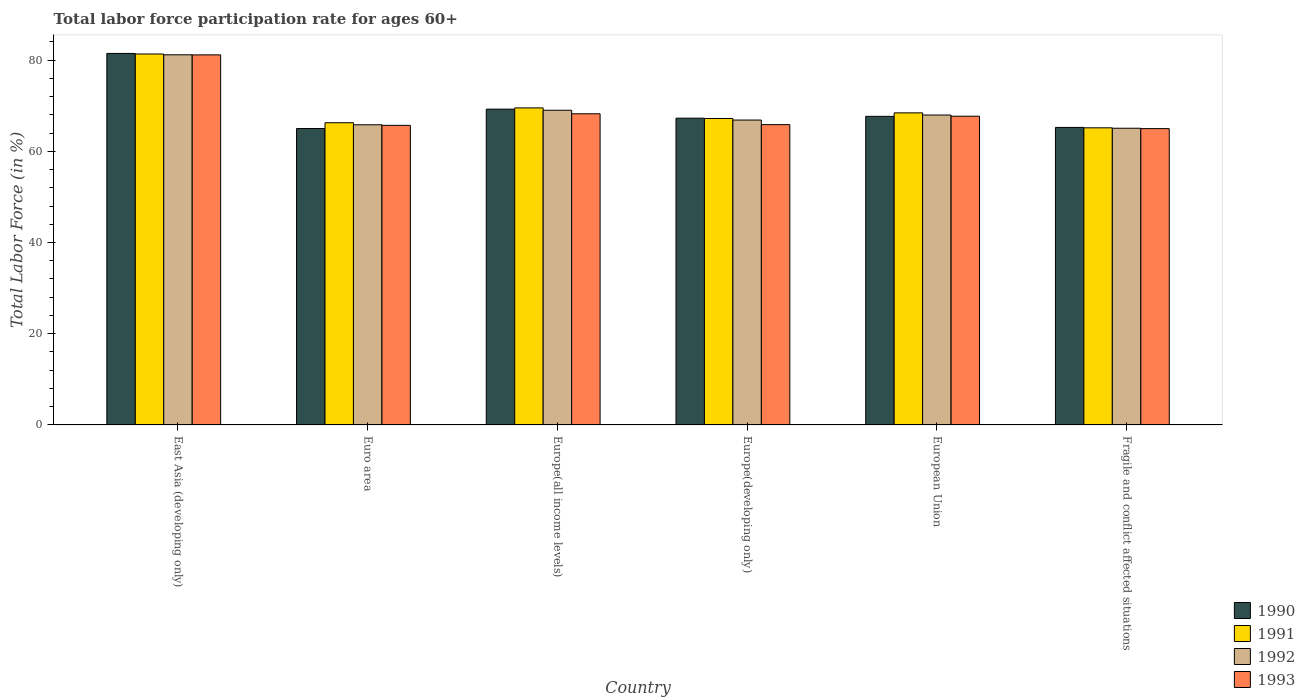Are the number of bars on each tick of the X-axis equal?
Your answer should be compact. Yes. In how many cases, is the number of bars for a given country not equal to the number of legend labels?
Give a very brief answer. 0. What is the labor force participation rate in 1993 in Euro area?
Provide a succinct answer. 65.69. Across all countries, what is the maximum labor force participation rate in 1991?
Provide a short and direct response. 81.33. Across all countries, what is the minimum labor force participation rate in 1990?
Provide a succinct answer. 65. In which country was the labor force participation rate in 1991 maximum?
Your answer should be compact. East Asia (developing only). In which country was the labor force participation rate in 1993 minimum?
Give a very brief answer. Fragile and conflict affected situations. What is the total labor force participation rate in 1991 in the graph?
Offer a terse response. 417.86. What is the difference between the labor force participation rate in 1991 in Euro area and that in Europe(developing only)?
Your answer should be compact. -0.93. What is the difference between the labor force participation rate in 1990 in European Union and the labor force participation rate in 1991 in East Asia (developing only)?
Provide a succinct answer. -13.67. What is the average labor force participation rate in 1990 per country?
Provide a succinct answer. 69.31. What is the difference between the labor force participation rate of/in 1992 and labor force participation rate of/in 1991 in East Asia (developing only)?
Make the answer very short. -0.17. What is the ratio of the labor force participation rate in 1991 in East Asia (developing only) to that in European Union?
Your answer should be compact. 1.19. What is the difference between the highest and the second highest labor force participation rate in 1991?
Make the answer very short. 12.91. What is the difference between the highest and the lowest labor force participation rate in 1990?
Keep it short and to the point. 16.45. Is the sum of the labor force participation rate in 1991 in Europe(all income levels) and European Union greater than the maximum labor force participation rate in 1992 across all countries?
Offer a terse response. Yes. What does the 1st bar from the right in Europe(developing only) represents?
Offer a very short reply. 1993. Is it the case that in every country, the sum of the labor force participation rate in 1992 and labor force participation rate in 1991 is greater than the labor force participation rate in 1993?
Your answer should be very brief. Yes. Are all the bars in the graph horizontal?
Keep it short and to the point. No. What is the difference between two consecutive major ticks on the Y-axis?
Offer a very short reply. 20. Does the graph contain grids?
Offer a very short reply. No. How are the legend labels stacked?
Give a very brief answer. Vertical. What is the title of the graph?
Your answer should be very brief. Total labor force participation rate for ages 60+. What is the label or title of the X-axis?
Provide a succinct answer. Country. What is the Total Labor Force (in %) of 1990 in East Asia (developing only)?
Make the answer very short. 81.45. What is the Total Labor Force (in %) of 1991 in East Asia (developing only)?
Keep it short and to the point. 81.33. What is the Total Labor Force (in %) in 1992 in East Asia (developing only)?
Provide a succinct answer. 81.16. What is the Total Labor Force (in %) in 1993 in East Asia (developing only)?
Offer a very short reply. 81.14. What is the Total Labor Force (in %) in 1990 in Euro area?
Keep it short and to the point. 65. What is the Total Labor Force (in %) in 1991 in Euro area?
Give a very brief answer. 66.26. What is the Total Labor Force (in %) of 1992 in Euro area?
Keep it short and to the point. 65.81. What is the Total Labor Force (in %) of 1993 in Euro area?
Your response must be concise. 65.69. What is the Total Labor Force (in %) of 1990 in Europe(all income levels)?
Give a very brief answer. 69.24. What is the Total Labor Force (in %) of 1991 in Europe(all income levels)?
Make the answer very short. 69.51. What is the Total Labor Force (in %) in 1992 in Europe(all income levels)?
Provide a succinct answer. 68.99. What is the Total Labor Force (in %) in 1993 in Europe(all income levels)?
Make the answer very short. 68.22. What is the Total Labor Force (in %) in 1990 in Europe(developing only)?
Offer a terse response. 67.26. What is the Total Labor Force (in %) in 1991 in Europe(developing only)?
Offer a very short reply. 67.19. What is the Total Labor Force (in %) of 1992 in Europe(developing only)?
Offer a very short reply. 66.85. What is the Total Labor Force (in %) of 1993 in Europe(developing only)?
Your response must be concise. 65.84. What is the Total Labor Force (in %) of 1990 in European Union?
Ensure brevity in your answer.  67.66. What is the Total Labor Force (in %) in 1991 in European Union?
Give a very brief answer. 68.42. What is the Total Labor Force (in %) of 1992 in European Union?
Your response must be concise. 67.95. What is the Total Labor Force (in %) in 1993 in European Union?
Ensure brevity in your answer.  67.69. What is the Total Labor Force (in %) in 1990 in Fragile and conflict affected situations?
Offer a very short reply. 65.24. What is the Total Labor Force (in %) in 1991 in Fragile and conflict affected situations?
Ensure brevity in your answer.  65.15. What is the Total Labor Force (in %) of 1992 in Fragile and conflict affected situations?
Offer a very short reply. 65.05. What is the Total Labor Force (in %) of 1993 in Fragile and conflict affected situations?
Your answer should be compact. 64.97. Across all countries, what is the maximum Total Labor Force (in %) in 1990?
Offer a terse response. 81.45. Across all countries, what is the maximum Total Labor Force (in %) in 1991?
Your response must be concise. 81.33. Across all countries, what is the maximum Total Labor Force (in %) in 1992?
Provide a succinct answer. 81.16. Across all countries, what is the maximum Total Labor Force (in %) of 1993?
Your response must be concise. 81.14. Across all countries, what is the minimum Total Labor Force (in %) in 1990?
Ensure brevity in your answer.  65. Across all countries, what is the minimum Total Labor Force (in %) in 1991?
Offer a terse response. 65.15. Across all countries, what is the minimum Total Labor Force (in %) in 1992?
Your answer should be compact. 65.05. Across all countries, what is the minimum Total Labor Force (in %) of 1993?
Give a very brief answer. 64.97. What is the total Total Labor Force (in %) of 1990 in the graph?
Make the answer very short. 415.85. What is the total Total Labor Force (in %) in 1991 in the graph?
Make the answer very short. 417.86. What is the total Total Labor Force (in %) in 1992 in the graph?
Keep it short and to the point. 415.81. What is the total Total Labor Force (in %) in 1993 in the graph?
Your answer should be compact. 413.55. What is the difference between the Total Labor Force (in %) of 1990 in East Asia (developing only) and that in Euro area?
Your answer should be very brief. 16.45. What is the difference between the Total Labor Force (in %) of 1991 in East Asia (developing only) and that in Euro area?
Your answer should be very brief. 15.07. What is the difference between the Total Labor Force (in %) in 1992 in East Asia (developing only) and that in Euro area?
Give a very brief answer. 15.34. What is the difference between the Total Labor Force (in %) of 1993 in East Asia (developing only) and that in Euro area?
Your answer should be compact. 15.45. What is the difference between the Total Labor Force (in %) in 1990 in East Asia (developing only) and that in Europe(all income levels)?
Offer a very short reply. 12.21. What is the difference between the Total Labor Force (in %) in 1991 in East Asia (developing only) and that in Europe(all income levels)?
Make the answer very short. 11.82. What is the difference between the Total Labor Force (in %) of 1992 in East Asia (developing only) and that in Europe(all income levels)?
Keep it short and to the point. 12.17. What is the difference between the Total Labor Force (in %) in 1993 in East Asia (developing only) and that in Europe(all income levels)?
Your answer should be compact. 12.91. What is the difference between the Total Labor Force (in %) of 1990 in East Asia (developing only) and that in Europe(developing only)?
Keep it short and to the point. 14.2. What is the difference between the Total Labor Force (in %) in 1991 in East Asia (developing only) and that in Europe(developing only)?
Your answer should be compact. 14.14. What is the difference between the Total Labor Force (in %) of 1992 in East Asia (developing only) and that in Europe(developing only)?
Keep it short and to the point. 14.31. What is the difference between the Total Labor Force (in %) of 1993 in East Asia (developing only) and that in Europe(developing only)?
Ensure brevity in your answer.  15.29. What is the difference between the Total Labor Force (in %) in 1990 in East Asia (developing only) and that in European Union?
Your answer should be compact. 13.79. What is the difference between the Total Labor Force (in %) in 1991 in East Asia (developing only) and that in European Union?
Provide a succinct answer. 12.91. What is the difference between the Total Labor Force (in %) of 1992 in East Asia (developing only) and that in European Union?
Keep it short and to the point. 13.21. What is the difference between the Total Labor Force (in %) in 1993 in East Asia (developing only) and that in European Union?
Keep it short and to the point. 13.45. What is the difference between the Total Labor Force (in %) of 1990 in East Asia (developing only) and that in Fragile and conflict affected situations?
Provide a short and direct response. 16.22. What is the difference between the Total Labor Force (in %) in 1991 in East Asia (developing only) and that in Fragile and conflict affected situations?
Provide a succinct answer. 16.19. What is the difference between the Total Labor Force (in %) in 1992 in East Asia (developing only) and that in Fragile and conflict affected situations?
Offer a terse response. 16.1. What is the difference between the Total Labor Force (in %) in 1993 in East Asia (developing only) and that in Fragile and conflict affected situations?
Make the answer very short. 16.17. What is the difference between the Total Labor Force (in %) of 1990 in Euro area and that in Europe(all income levels)?
Your answer should be very brief. -4.24. What is the difference between the Total Labor Force (in %) of 1991 in Euro area and that in Europe(all income levels)?
Make the answer very short. -3.25. What is the difference between the Total Labor Force (in %) in 1992 in Euro area and that in Europe(all income levels)?
Your answer should be very brief. -3.18. What is the difference between the Total Labor Force (in %) of 1993 in Euro area and that in Europe(all income levels)?
Make the answer very short. -2.54. What is the difference between the Total Labor Force (in %) in 1990 in Euro area and that in Europe(developing only)?
Ensure brevity in your answer.  -2.26. What is the difference between the Total Labor Force (in %) of 1991 in Euro area and that in Europe(developing only)?
Your answer should be compact. -0.93. What is the difference between the Total Labor Force (in %) in 1992 in Euro area and that in Europe(developing only)?
Ensure brevity in your answer.  -1.03. What is the difference between the Total Labor Force (in %) of 1993 in Euro area and that in Europe(developing only)?
Offer a terse response. -0.16. What is the difference between the Total Labor Force (in %) in 1990 in Euro area and that in European Union?
Give a very brief answer. -2.66. What is the difference between the Total Labor Force (in %) of 1991 in Euro area and that in European Union?
Your response must be concise. -2.16. What is the difference between the Total Labor Force (in %) of 1992 in Euro area and that in European Union?
Your response must be concise. -2.14. What is the difference between the Total Labor Force (in %) of 1993 in Euro area and that in European Union?
Provide a succinct answer. -2.01. What is the difference between the Total Labor Force (in %) of 1990 in Euro area and that in Fragile and conflict affected situations?
Offer a terse response. -0.24. What is the difference between the Total Labor Force (in %) of 1991 in Euro area and that in Fragile and conflict affected situations?
Ensure brevity in your answer.  1.11. What is the difference between the Total Labor Force (in %) in 1992 in Euro area and that in Fragile and conflict affected situations?
Give a very brief answer. 0.76. What is the difference between the Total Labor Force (in %) of 1993 in Euro area and that in Fragile and conflict affected situations?
Keep it short and to the point. 0.72. What is the difference between the Total Labor Force (in %) in 1990 in Europe(all income levels) and that in Europe(developing only)?
Your response must be concise. 1.99. What is the difference between the Total Labor Force (in %) of 1991 in Europe(all income levels) and that in Europe(developing only)?
Offer a very short reply. 2.33. What is the difference between the Total Labor Force (in %) of 1992 in Europe(all income levels) and that in Europe(developing only)?
Give a very brief answer. 2.15. What is the difference between the Total Labor Force (in %) in 1993 in Europe(all income levels) and that in Europe(developing only)?
Offer a very short reply. 2.38. What is the difference between the Total Labor Force (in %) of 1990 in Europe(all income levels) and that in European Union?
Offer a very short reply. 1.58. What is the difference between the Total Labor Force (in %) in 1991 in Europe(all income levels) and that in European Union?
Your answer should be compact. 1.09. What is the difference between the Total Labor Force (in %) of 1992 in Europe(all income levels) and that in European Union?
Your response must be concise. 1.04. What is the difference between the Total Labor Force (in %) in 1993 in Europe(all income levels) and that in European Union?
Ensure brevity in your answer.  0.53. What is the difference between the Total Labor Force (in %) of 1990 in Europe(all income levels) and that in Fragile and conflict affected situations?
Ensure brevity in your answer.  4.01. What is the difference between the Total Labor Force (in %) in 1991 in Europe(all income levels) and that in Fragile and conflict affected situations?
Give a very brief answer. 4.37. What is the difference between the Total Labor Force (in %) in 1992 in Europe(all income levels) and that in Fragile and conflict affected situations?
Offer a very short reply. 3.94. What is the difference between the Total Labor Force (in %) in 1993 in Europe(all income levels) and that in Fragile and conflict affected situations?
Keep it short and to the point. 3.26. What is the difference between the Total Labor Force (in %) of 1990 in Europe(developing only) and that in European Union?
Your answer should be very brief. -0.4. What is the difference between the Total Labor Force (in %) of 1991 in Europe(developing only) and that in European Union?
Make the answer very short. -1.24. What is the difference between the Total Labor Force (in %) in 1992 in Europe(developing only) and that in European Union?
Give a very brief answer. -1.1. What is the difference between the Total Labor Force (in %) of 1993 in Europe(developing only) and that in European Union?
Your answer should be compact. -1.85. What is the difference between the Total Labor Force (in %) of 1990 in Europe(developing only) and that in Fragile and conflict affected situations?
Give a very brief answer. 2.02. What is the difference between the Total Labor Force (in %) of 1991 in Europe(developing only) and that in Fragile and conflict affected situations?
Provide a succinct answer. 2.04. What is the difference between the Total Labor Force (in %) in 1992 in Europe(developing only) and that in Fragile and conflict affected situations?
Your answer should be very brief. 1.79. What is the difference between the Total Labor Force (in %) of 1993 in Europe(developing only) and that in Fragile and conflict affected situations?
Offer a very short reply. 0.87. What is the difference between the Total Labor Force (in %) of 1990 in European Union and that in Fragile and conflict affected situations?
Your response must be concise. 2.42. What is the difference between the Total Labor Force (in %) of 1991 in European Union and that in Fragile and conflict affected situations?
Keep it short and to the point. 3.28. What is the difference between the Total Labor Force (in %) of 1992 in European Union and that in Fragile and conflict affected situations?
Ensure brevity in your answer.  2.9. What is the difference between the Total Labor Force (in %) of 1993 in European Union and that in Fragile and conflict affected situations?
Your response must be concise. 2.72. What is the difference between the Total Labor Force (in %) in 1990 in East Asia (developing only) and the Total Labor Force (in %) in 1991 in Euro area?
Keep it short and to the point. 15.19. What is the difference between the Total Labor Force (in %) of 1990 in East Asia (developing only) and the Total Labor Force (in %) of 1992 in Euro area?
Give a very brief answer. 15.64. What is the difference between the Total Labor Force (in %) of 1990 in East Asia (developing only) and the Total Labor Force (in %) of 1993 in Euro area?
Your response must be concise. 15.77. What is the difference between the Total Labor Force (in %) of 1991 in East Asia (developing only) and the Total Labor Force (in %) of 1992 in Euro area?
Provide a succinct answer. 15.52. What is the difference between the Total Labor Force (in %) of 1991 in East Asia (developing only) and the Total Labor Force (in %) of 1993 in Euro area?
Give a very brief answer. 15.65. What is the difference between the Total Labor Force (in %) in 1992 in East Asia (developing only) and the Total Labor Force (in %) in 1993 in Euro area?
Offer a terse response. 15.47. What is the difference between the Total Labor Force (in %) in 1990 in East Asia (developing only) and the Total Labor Force (in %) in 1991 in Europe(all income levels)?
Make the answer very short. 11.94. What is the difference between the Total Labor Force (in %) of 1990 in East Asia (developing only) and the Total Labor Force (in %) of 1992 in Europe(all income levels)?
Offer a terse response. 12.46. What is the difference between the Total Labor Force (in %) of 1990 in East Asia (developing only) and the Total Labor Force (in %) of 1993 in Europe(all income levels)?
Your answer should be compact. 13.23. What is the difference between the Total Labor Force (in %) of 1991 in East Asia (developing only) and the Total Labor Force (in %) of 1992 in Europe(all income levels)?
Keep it short and to the point. 12.34. What is the difference between the Total Labor Force (in %) in 1991 in East Asia (developing only) and the Total Labor Force (in %) in 1993 in Europe(all income levels)?
Offer a very short reply. 13.11. What is the difference between the Total Labor Force (in %) of 1992 in East Asia (developing only) and the Total Labor Force (in %) of 1993 in Europe(all income levels)?
Provide a short and direct response. 12.93. What is the difference between the Total Labor Force (in %) of 1990 in East Asia (developing only) and the Total Labor Force (in %) of 1991 in Europe(developing only)?
Offer a very short reply. 14.27. What is the difference between the Total Labor Force (in %) in 1990 in East Asia (developing only) and the Total Labor Force (in %) in 1992 in Europe(developing only)?
Your answer should be compact. 14.61. What is the difference between the Total Labor Force (in %) of 1990 in East Asia (developing only) and the Total Labor Force (in %) of 1993 in Europe(developing only)?
Give a very brief answer. 15.61. What is the difference between the Total Labor Force (in %) in 1991 in East Asia (developing only) and the Total Labor Force (in %) in 1992 in Europe(developing only)?
Give a very brief answer. 14.49. What is the difference between the Total Labor Force (in %) of 1991 in East Asia (developing only) and the Total Labor Force (in %) of 1993 in Europe(developing only)?
Your answer should be compact. 15.49. What is the difference between the Total Labor Force (in %) in 1992 in East Asia (developing only) and the Total Labor Force (in %) in 1993 in Europe(developing only)?
Ensure brevity in your answer.  15.31. What is the difference between the Total Labor Force (in %) in 1990 in East Asia (developing only) and the Total Labor Force (in %) in 1991 in European Union?
Keep it short and to the point. 13.03. What is the difference between the Total Labor Force (in %) of 1990 in East Asia (developing only) and the Total Labor Force (in %) of 1992 in European Union?
Make the answer very short. 13.5. What is the difference between the Total Labor Force (in %) in 1990 in East Asia (developing only) and the Total Labor Force (in %) in 1993 in European Union?
Give a very brief answer. 13.76. What is the difference between the Total Labor Force (in %) of 1991 in East Asia (developing only) and the Total Labor Force (in %) of 1992 in European Union?
Make the answer very short. 13.38. What is the difference between the Total Labor Force (in %) in 1991 in East Asia (developing only) and the Total Labor Force (in %) in 1993 in European Union?
Provide a succinct answer. 13.64. What is the difference between the Total Labor Force (in %) in 1992 in East Asia (developing only) and the Total Labor Force (in %) in 1993 in European Union?
Offer a terse response. 13.47. What is the difference between the Total Labor Force (in %) in 1990 in East Asia (developing only) and the Total Labor Force (in %) in 1991 in Fragile and conflict affected situations?
Provide a succinct answer. 16.31. What is the difference between the Total Labor Force (in %) of 1990 in East Asia (developing only) and the Total Labor Force (in %) of 1992 in Fragile and conflict affected situations?
Give a very brief answer. 16.4. What is the difference between the Total Labor Force (in %) of 1990 in East Asia (developing only) and the Total Labor Force (in %) of 1993 in Fragile and conflict affected situations?
Make the answer very short. 16.48. What is the difference between the Total Labor Force (in %) of 1991 in East Asia (developing only) and the Total Labor Force (in %) of 1992 in Fragile and conflict affected situations?
Offer a very short reply. 16.28. What is the difference between the Total Labor Force (in %) of 1991 in East Asia (developing only) and the Total Labor Force (in %) of 1993 in Fragile and conflict affected situations?
Offer a very short reply. 16.36. What is the difference between the Total Labor Force (in %) in 1992 in East Asia (developing only) and the Total Labor Force (in %) in 1993 in Fragile and conflict affected situations?
Offer a very short reply. 16.19. What is the difference between the Total Labor Force (in %) of 1990 in Euro area and the Total Labor Force (in %) of 1991 in Europe(all income levels)?
Your response must be concise. -4.51. What is the difference between the Total Labor Force (in %) of 1990 in Euro area and the Total Labor Force (in %) of 1992 in Europe(all income levels)?
Ensure brevity in your answer.  -3.99. What is the difference between the Total Labor Force (in %) in 1990 in Euro area and the Total Labor Force (in %) in 1993 in Europe(all income levels)?
Keep it short and to the point. -3.22. What is the difference between the Total Labor Force (in %) of 1991 in Euro area and the Total Labor Force (in %) of 1992 in Europe(all income levels)?
Your response must be concise. -2.73. What is the difference between the Total Labor Force (in %) of 1991 in Euro area and the Total Labor Force (in %) of 1993 in Europe(all income levels)?
Give a very brief answer. -1.97. What is the difference between the Total Labor Force (in %) of 1992 in Euro area and the Total Labor Force (in %) of 1993 in Europe(all income levels)?
Offer a terse response. -2.41. What is the difference between the Total Labor Force (in %) of 1990 in Euro area and the Total Labor Force (in %) of 1991 in Europe(developing only)?
Offer a very short reply. -2.19. What is the difference between the Total Labor Force (in %) of 1990 in Euro area and the Total Labor Force (in %) of 1992 in Europe(developing only)?
Offer a terse response. -1.85. What is the difference between the Total Labor Force (in %) in 1990 in Euro area and the Total Labor Force (in %) in 1993 in Europe(developing only)?
Your response must be concise. -0.84. What is the difference between the Total Labor Force (in %) in 1991 in Euro area and the Total Labor Force (in %) in 1992 in Europe(developing only)?
Your answer should be compact. -0.59. What is the difference between the Total Labor Force (in %) of 1991 in Euro area and the Total Labor Force (in %) of 1993 in Europe(developing only)?
Make the answer very short. 0.42. What is the difference between the Total Labor Force (in %) in 1992 in Euro area and the Total Labor Force (in %) in 1993 in Europe(developing only)?
Your answer should be very brief. -0.03. What is the difference between the Total Labor Force (in %) in 1990 in Euro area and the Total Labor Force (in %) in 1991 in European Union?
Your response must be concise. -3.42. What is the difference between the Total Labor Force (in %) of 1990 in Euro area and the Total Labor Force (in %) of 1992 in European Union?
Keep it short and to the point. -2.95. What is the difference between the Total Labor Force (in %) in 1990 in Euro area and the Total Labor Force (in %) in 1993 in European Union?
Offer a terse response. -2.69. What is the difference between the Total Labor Force (in %) in 1991 in Euro area and the Total Labor Force (in %) in 1992 in European Union?
Keep it short and to the point. -1.69. What is the difference between the Total Labor Force (in %) in 1991 in Euro area and the Total Labor Force (in %) in 1993 in European Union?
Make the answer very short. -1.43. What is the difference between the Total Labor Force (in %) of 1992 in Euro area and the Total Labor Force (in %) of 1993 in European Union?
Your response must be concise. -1.88. What is the difference between the Total Labor Force (in %) of 1990 in Euro area and the Total Labor Force (in %) of 1991 in Fragile and conflict affected situations?
Make the answer very short. -0.15. What is the difference between the Total Labor Force (in %) of 1990 in Euro area and the Total Labor Force (in %) of 1992 in Fragile and conflict affected situations?
Your answer should be compact. -0.05. What is the difference between the Total Labor Force (in %) of 1990 in Euro area and the Total Labor Force (in %) of 1993 in Fragile and conflict affected situations?
Keep it short and to the point. 0.03. What is the difference between the Total Labor Force (in %) of 1991 in Euro area and the Total Labor Force (in %) of 1992 in Fragile and conflict affected situations?
Make the answer very short. 1.21. What is the difference between the Total Labor Force (in %) of 1991 in Euro area and the Total Labor Force (in %) of 1993 in Fragile and conflict affected situations?
Provide a succinct answer. 1.29. What is the difference between the Total Labor Force (in %) of 1992 in Euro area and the Total Labor Force (in %) of 1993 in Fragile and conflict affected situations?
Provide a succinct answer. 0.84. What is the difference between the Total Labor Force (in %) in 1990 in Europe(all income levels) and the Total Labor Force (in %) in 1991 in Europe(developing only)?
Give a very brief answer. 2.06. What is the difference between the Total Labor Force (in %) in 1990 in Europe(all income levels) and the Total Labor Force (in %) in 1992 in Europe(developing only)?
Ensure brevity in your answer.  2.4. What is the difference between the Total Labor Force (in %) of 1990 in Europe(all income levels) and the Total Labor Force (in %) of 1993 in Europe(developing only)?
Your answer should be compact. 3.4. What is the difference between the Total Labor Force (in %) of 1991 in Europe(all income levels) and the Total Labor Force (in %) of 1992 in Europe(developing only)?
Offer a terse response. 2.67. What is the difference between the Total Labor Force (in %) in 1991 in Europe(all income levels) and the Total Labor Force (in %) in 1993 in Europe(developing only)?
Give a very brief answer. 3.67. What is the difference between the Total Labor Force (in %) in 1992 in Europe(all income levels) and the Total Labor Force (in %) in 1993 in Europe(developing only)?
Make the answer very short. 3.15. What is the difference between the Total Labor Force (in %) in 1990 in Europe(all income levels) and the Total Labor Force (in %) in 1991 in European Union?
Your answer should be compact. 0.82. What is the difference between the Total Labor Force (in %) in 1990 in Europe(all income levels) and the Total Labor Force (in %) in 1992 in European Union?
Your answer should be compact. 1.29. What is the difference between the Total Labor Force (in %) of 1990 in Europe(all income levels) and the Total Labor Force (in %) of 1993 in European Union?
Offer a terse response. 1.55. What is the difference between the Total Labor Force (in %) of 1991 in Europe(all income levels) and the Total Labor Force (in %) of 1992 in European Union?
Keep it short and to the point. 1.56. What is the difference between the Total Labor Force (in %) in 1991 in Europe(all income levels) and the Total Labor Force (in %) in 1993 in European Union?
Your answer should be compact. 1.82. What is the difference between the Total Labor Force (in %) of 1992 in Europe(all income levels) and the Total Labor Force (in %) of 1993 in European Union?
Provide a succinct answer. 1.3. What is the difference between the Total Labor Force (in %) in 1990 in Europe(all income levels) and the Total Labor Force (in %) in 1991 in Fragile and conflict affected situations?
Your answer should be very brief. 4.1. What is the difference between the Total Labor Force (in %) in 1990 in Europe(all income levels) and the Total Labor Force (in %) in 1992 in Fragile and conflict affected situations?
Your answer should be compact. 4.19. What is the difference between the Total Labor Force (in %) of 1990 in Europe(all income levels) and the Total Labor Force (in %) of 1993 in Fragile and conflict affected situations?
Keep it short and to the point. 4.28. What is the difference between the Total Labor Force (in %) of 1991 in Europe(all income levels) and the Total Labor Force (in %) of 1992 in Fragile and conflict affected situations?
Your answer should be compact. 4.46. What is the difference between the Total Labor Force (in %) of 1991 in Europe(all income levels) and the Total Labor Force (in %) of 1993 in Fragile and conflict affected situations?
Offer a terse response. 4.54. What is the difference between the Total Labor Force (in %) in 1992 in Europe(all income levels) and the Total Labor Force (in %) in 1993 in Fragile and conflict affected situations?
Provide a short and direct response. 4.02. What is the difference between the Total Labor Force (in %) in 1990 in Europe(developing only) and the Total Labor Force (in %) in 1991 in European Union?
Offer a very short reply. -1.16. What is the difference between the Total Labor Force (in %) of 1990 in Europe(developing only) and the Total Labor Force (in %) of 1992 in European Union?
Make the answer very short. -0.69. What is the difference between the Total Labor Force (in %) in 1990 in Europe(developing only) and the Total Labor Force (in %) in 1993 in European Union?
Your answer should be compact. -0.43. What is the difference between the Total Labor Force (in %) of 1991 in Europe(developing only) and the Total Labor Force (in %) of 1992 in European Union?
Provide a short and direct response. -0.76. What is the difference between the Total Labor Force (in %) in 1991 in Europe(developing only) and the Total Labor Force (in %) in 1993 in European Union?
Offer a terse response. -0.51. What is the difference between the Total Labor Force (in %) of 1992 in Europe(developing only) and the Total Labor Force (in %) of 1993 in European Union?
Give a very brief answer. -0.85. What is the difference between the Total Labor Force (in %) of 1990 in Europe(developing only) and the Total Labor Force (in %) of 1991 in Fragile and conflict affected situations?
Provide a short and direct response. 2.11. What is the difference between the Total Labor Force (in %) in 1990 in Europe(developing only) and the Total Labor Force (in %) in 1992 in Fragile and conflict affected situations?
Offer a very short reply. 2.21. What is the difference between the Total Labor Force (in %) in 1990 in Europe(developing only) and the Total Labor Force (in %) in 1993 in Fragile and conflict affected situations?
Your answer should be very brief. 2.29. What is the difference between the Total Labor Force (in %) of 1991 in Europe(developing only) and the Total Labor Force (in %) of 1992 in Fragile and conflict affected situations?
Give a very brief answer. 2.13. What is the difference between the Total Labor Force (in %) of 1991 in Europe(developing only) and the Total Labor Force (in %) of 1993 in Fragile and conflict affected situations?
Make the answer very short. 2.22. What is the difference between the Total Labor Force (in %) of 1992 in Europe(developing only) and the Total Labor Force (in %) of 1993 in Fragile and conflict affected situations?
Offer a terse response. 1.88. What is the difference between the Total Labor Force (in %) of 1990 in European Union and the Total Labor Force (in %) of 1991 in Fragile and conflict affected situations?
Offer a very short reply. 2.51. What is the difference between the Total Labor Force (in %) in 1990 in European Union and the Total Labor Force (in %) in 1992 in Fragile and conflict affected situations?
Ensure brevity in your answer.  2.61. What is the difference between the Total Labor Force (in %) of 1990 in European Union and the Total Labor Force (in %) of 1993 in Fragile and conflict affected situations?
Provide a short and direct response. 2.69. What is the difference between the Total Labor Force (in %) of 1991 in European Union and the Total Labor Force (in %) of 1992 in Fragile and conflict affected situations?
Provide a succinct answer. 3.37. What is the difference between the Total Labor Force (in %) of 1991 in European Union and the Total Labor Force (in %) of 1993 in Fragile and conflict affected situations?
Provide a short and direct response. 3.45. What is the difference between the Total Labor Force (in %) in 1992 in European Union and the Total Labor Force (in %) in 1993 in Fragile and conflict affected situations?
Keep it short and to the point. 2.98. What is the average Total Labor Force (in %) in 1990 per country?
Give a very brief answer. 69.31. What is the average Total Labor Force (in %) in 1991 per country?
Keep it short and to the point. 69.64. What is the average Total Labor Force (in %) in 1992 per country?
Give a very brief answer. 69.3. What is the average Total Labor Force (in %) of 1993 per country?
Offer a very short reply. 68.93. What is the difference between the Total Labor Force (in %) in 1990 and Total Labor Force (in %) in 1991 in East Asia (developing only)?
Give a very brief answer. 0.12. What is the difference between the Total Labor Force (in %) of 1990 and Total Labor Force (in %) of 1992 in East Asia (developing only)?
Provide a short and direct response. 0.3. What is the difference between the Total Labor Force (in %) of 1990 and Total Labor Force (in %) of 1993 in East Asia (developing only)?
Keep it short and to the point. 0.32. What is the difference between the Total Labor Force (in %) in 1991 and Total Labor Force (in %) in 1992 in East Asia (developing only)?
Keep it short and to the point. 0.17. What is the difference between the Total Labor Force (in %) of 1991 and Total Labor Force (in %) of 1993 in East Asia (developing only)?
Offer a very short reply. 0.19. What is the difference between the Total Labor Force (in %) of 1992 and Total Labor Force (in %) of 1993 in East Asia (developing only)?
Offer a very short reply. 0.02. What is the difference between the Total Labor Force (in %) in 1990 and Total Labor Force (in %) in 1991 in Euro area?
Offer a terse response. -1.26. What is the difference between the Total Labor Force (in %) of 1990 and Total Labor Force (in %) of 1992 in Euro area?
Offer a terse response. -0.81. What is the difference between the Total Labor Force (in %) of 1990 and Total Labor Force (in %) of 1993 in Euro area?
Offer a very short reply. -0.69. What is the difference between the Total Labor Force (in %) in 1991 and Total Labor Force (in %) in 1992 in Euro area?
Provide a short and direct response. 0.45. What is the difference between the Total Labor Force (in %) in 1991 and Total Labor Force (in %) in 1993 in Euro area?
Ensure brevity in your answer.  0.57. What is the difference between the Total Labor Force (in %) of 1992 and Total Labor Force (in %) of 1993 in Euro area?
Make the answer very short. 0.13. What is the difference between the Total Labor Force (in %) in 1990 and Total Labor Force (in %) in 1991 in Europe(all income levels)?
Your answer should be compact. -0.27. What is the difference between the Total Labor Force (in %) in 1990 and Total Labor Force (in %) in 1992 in Europe(all income levels)?
Your response must be concise. 0.25. What is the difference between the Total Labor Force (in %) of 1990 and Total Labor Force (in %) of 1993 in Europe(all income levels)?
Your response must be concise. 1.02. What is the difference between the Total Labor Force (in %) of 1991 and Total Labor Force (in %) of 1992 in Europe(all income levels)?
Offer a very short reply. 0.52. What is the difference between the Total Labor Force (in %) of 1991 and Total Labor Force (in %) of 1993 in Europe(all income levels)?
Give a very brief answer. 1.29. What is the difference between the Total Labor Force (in %) of 1992 and Total Labor Force (in %) of 1993 in Europe(all income levels)?
Give a very brief answer. 0.77. What is the difference between the Total Labor Force (in %) of 1990 and Total Labor Force (in %) of 1991 in Europe(developing only)?
Offer a terse response. 0.07. What is the difference between the Total Labor Force (in %) of 1990 and Total Labor Force (in %) of 1992 in Europe(developing only)?
Give a very brief answer. 0.41. What is the difference between the Total Labor Force (in %) of 1990 and Total Labor Force (in %) of 1993 in Europe(developing only)?
Ensure brevity in your answer.  1.42. What is the difference between the Total Labor Force (in %) of 1991 and Total Labor Force (in %) of 1992 in Europe(developing only)?
Your answer should be compact. 0.34. What is the difference between the Total Labor Force (in %) in 1991 and Total Labor Force (in %) in 1993 in Europe(developing only)?
Give a very brief answer. 1.34. What is the difference between the Total Labor Force (in %) in 1990 and Total Labor Force (in %) in 1991 in European Union?
Keep it short and to the point. -0.76. What is the difference between the Total Labor Force (in %) of 1990 and Total Labor Force (in %) of 1992 in European Union?
Provide a short and direct response. -0.29. What is the difference between the Total Labor Force (in %) of 1990 and Total Labor Force (in %) of 1993 in European Union?
Make the answer very short. -0.03. What is the difference between the Total Labor Force (in %) of 1991 and Total Labor Force (in %) of 1992 in European Union?
Keep it short and to the point. 0.47. What is the difference between the Total Labor Force (in %) of 1991 and Total Labor Force (in %) of 1993 in European Union?
Give a very brief answer. 0.73. What is the difference between the Total Labor Force (in %) of 1992 and Total Labor Force (in %) of 1993 in European Union?
Give a very brief answer. 0.26. What is the difference between the Total Labor Force (in %) in 1990 and Total Labor Force (in %) in 1991 in Fragile and conflict affected situations?
Ensure brevity in your answer.  0.09. What is the difference between the Total Labor Force (in %) in 1990 and Total Labor Force (in %) in 1992 in Fragile and conflict affected situations?
Keep it short and to the point. 0.18. What is the difference between the Total Labor Force (in %) in 1990 and Total Labor Force (in %) in 1993 in Fragile and conflict affected situations?
Your response must be concise. 0.27. What is the difference between the Total Labor Force (in %) of 1991 and Total Labor Force (in %) of 1992 in Fragile and conflict affected situations?
Your answer should be compact. 0.09. What is the difference between the Total Labor Force (in %) in 1991 and Total Labor Force (in %) in 1993 in Fragile and conflict affected situations?
Offer a terse response. 0.18. What is the difference between the Total Labor Force (in %) in 1992 and Total Labor Force (in %) in 1993 in Fragile and conflict affected situations?
Keep it short and to the point. 0.08. What is the ratio of the Total Labor Force (in %) in 1990 in East Asia (developing only) to that in Euro area?
Your response must be concise. 1.25. What is the ratio of the Total Labor Force (in %) in 1991 in East Asia (developing only) to that in Euro area?
Offer a terse response. 1.23. What is the ratio of the Total Labor Force (in %) in 1992 in East Asia (developing only) to that in Euro area?
Provide a short and direct response. 1.23. What is the ratio of the Total Labor Force (in %) of 1993 in East Asia (developing only) to that in Euro area?
Your response must be concise. 1.24. What is the ratio of the Total Labor Force (in %) in 1990 in East Asia (developing only) to that in Europe(all income levels)?
Provide a succinct answer. 1.18. What is the ratio of the Total Labor Force (in %) of 1991 in East Asia (developing only) to that in Europe(all income levels)?
Provide a short and direct response. 1.17. What is the ratio of the Total Labor Force (in %) of 1992 in East Asia (developing only) to that in Europe(all income levels)?
Give a very brief answer. 1.18. What is the ratio of the Total Labor Force (in %) of 1993 in East Asia (developing only) to that in Europe(all income levels)?
Provide a short and direct response. 1.19. What is the ratio of the Total Labor Force (in %) in 1990 in East Asia (developing only) to that in Europe(developing only)?
Your response must be concise. 1.21. What is the ratio of the Total Labor Force (in %) in 1991 in East Asia (developing only) to that in Europe(developing only)?
Make the answer very short. 1.21. What is the ratio of the Total Labor Force (in %) of 1992 in East Asia (developing only) to that in Europe(developing only)?
Offer a very short reply. 1.21. What is the ratio of the Total Labor Force (in %) in 1993 in East Asia (developing only) to that in Europe(developing only)?
Give a very brief answer. 1.23. What is the ratio of the Total Labor Force (in %) in 1990 in East Asia (developing only) to that in European Union?
Give a very brief answer. 1.2. What is the ratio of the Total Labor Force (in %) of 1991 in East Asia (developing only) to that in European Union?
Offer a very short reply. 1.19. What is the ratio of the Total Labor Force (in %) in 1992 in East Asia (developing only) to that in European Union?
Keep it short and to the point. 1.19. What is the ratio of the Total Labor Force (in %) in 1993 in East Asia (developing only) to that in European Union?
Provide a short and direct response. 1.2. What is the ratio of the Total Labor Force (in %) in 1990 in East Asia (developing only) to that in Fragile and conflict affected situations?
Your answer should be compact. 1.25. What is the ratio of the Total Labor Force (in %) of 1991 in East Asia (developing only) to that in Fragile and conflict affected situations?
Provide a succinct answer. 1.25. What is the ratio of the Total Labor Force (in %) of 1992 in East Asia (developing only) to that in Fragile and conflict affected situations?
Provide a short and direct response. 1.25. What is the ratio of the Total Labor Force (in %) in 1993 in East Asia (developing only) to that in Fragile and conflict affected situations?
Provide a short and direct response. 1.25. What is the ratio of the Total Labor Force (in %) of 1990 in Euro area to that in Europe(all income levels)?
Offer a very short reply. 0.94. What is the ratio of the Total Labor Force (in %) of 1991 in Euro area to that in Europe(all income levels)?
Provide a short and direct response. 0.95. What is the ratio of the Total Labor Force (in %) in 1992 in Euro area to that in Europe(all income levels)?
Ensure brevity in your answer.  0.95. What is the ratio of the Total Labor Force (in %) in 1993 in Euro area to that in Europe(all income levels)?
Your answer should be very brief. 0.96. What is the ratio of the Total Labor Force (in %) in 1990 in Euro area to that in Europe(developing only)?
Offer a very short reply. 0.97. What is the ratio of the Total Labor Force (in %) of 1991 in Euro area to that in Europe(developing only)?
Offer a very short reply. 0.99. What is the ratio of the Total Labor Force (in %) in 1992 in Euro area to that in Europe(developing only)?
Provide a short and direct response. 0.98. What is the ratio of the Total Labor Force (in %) of 1993 in Euro area to that in Europe(developing only)?
Your answer should be very brief. 1. What is the ratio of the Total Labor Force (in %) of 1990 in Euro area to that in European Union?
Offer a terse response. 0.96. What is the ratio of the Total Labor Force (in %) in 1991 in Euro area to that in European Union?
Provide a short and direct response. 0.97. What is the ratio of the Total Labor Force (in %) in 1992 in Euro area to that in European Union?
Your response must be concise. 0.97. What is the ratio of the Total Labor Force (in %) of 1993 in Euro area to that in European Union?
Ensure brevity in your answer.  0.97. What is the ratio of the Total Labor Force (in %) in 1991 in Euro area to that in Fragile and conflict affected situations?
Your answer should be compact. 1.02. What is the ratio of the Total Labor Force (in %) of 1992 in Euro area to that in Fragile and conflict affected situations?
Give a very brief answer. 1.01. What is the ratio of the Total Labor Force (in %) of 1990 in Europe(all income levels) to that in Europe(developing only)?
Provide a succinct answer. 1.03. What is the ratio of the Total Labor Force (in %) in 1991 in Europe(all income levels) to that in Europe(developing only)?
Give a very brief answer. 1.03. What is the ratio of the Total Labor Force (in %) of 1992 in Europe(all income levels) to that in Europe(developing only)?
Provide a succinct answer. 1.03. What is the ratio of the Total Labor Force (in %) of 1993 in Europe(all income levels) to that in Europe(developing only)?
Give a very brief answer. 1.04. What is the ratio of the Total Labor Force (in %) of 1990 in Europe(all income levels) to that in European Union?
Your response must be concise. 1.02. What is the ratio of the Total Labor Force (in %) in 1991 in Europe(all income levels) to that in European Union?
Ensure brevity in your answer.  1.02. What is the ratio of the Total Labor Force (in %) of 1992 in Europe(all income levels) to that in European Union?
Offer a very short reply. 1.02. What is the ratio of the Total Labor Force (in %) of 1993 in Europe(all income levels) to that in European Union?
Give a very brief answer. 1.01. What is the ratio of the Total Labor Force (in %) of 1990 in Europe(all income levels) to that in Fragile and conflict affected situations?
Your response must be concise. 1.06. What is the ratio of the Total Labor Force (in %) of 1991 in Europe(all income levels) to that in Fragile and conflict affected situations?
Your answer should be very brief. 1.07. What is the ratio of the Total Labor Force (in %) of 1992 in Europe(all income levels) to that in Fragile and conflict affected situations?
Give a very brief answer. 1.06. What is the ratio of the Total Labor Force (in %) in 1993 in Europe(all income levels) to that in Fragile and conflict affected situations?
Your answer should be compact. 1.05. What is the ratio of the Total Labor Force (in %) of 1991 in Europe(developing only) to that in European Union?
Provide a short and direct response. 0.98. What is the ratio of the Total Labor Force (in %) of 1992 in Europe(developing only) to that in European Union?
Provide a succinct answer. 0.98. What is the ratio of the Total Labor Force (in %) of 1993 in Europe(developing only) to that in European Union?
Your response must be concise. 0.97. What is the ratio of the Total Labor Force (in %) of 1990 in Europe(developing only) to that in Fragile and conflict affected situations?
Give a very brief answer. 1.03. What is the ratio of the Total Labor Force (in %) of 1991 in Europe(developing only) to that in Fragile and conflict affected situations?
Make the answer very short. 1.03. What is the ratio of the Total Labor Force (in %) of 1992 in Europe(developing only) to that in Fragile and conflict affected situations?
Give a very brief answer. 1.03. What is the ratio of the Total Labor Force (in %) of 1993 in Europe(developing only) to that in Fragile and conflict affected situations?
Give a very brief answer. 1.01. What is the ratio of the Total Labor Force (in %) of 1990 in European Union to that in Fragile and conflict affected situations?
Ensure brevity in your answer.  1.04. What is the ratio of the Total Labor Force (in %) in 1991 in European Union to that in Fragile and conflict affected situations?
Your response must be concise. 1.05. What is the ratio of the Total Labor Force (in %) of 1992 in European Union to that in Fragile and conflict affected situations?
Provide a succinct answer. 1.04. What is the ratio of the Total Labor Force (in %) of 1993 in European Union to that in Fragile and conflict affected situations?
Offer a very short reply. 1.04. What is the difference between the highest and the second highest Total Labor Force (in %) in 1990?
Provide a short and direct response. 12.21. What is the difference between the highest and the second highest Total Labor Force (in %) in 1991?
Your answer should be very brief. 11.82. What is the difference between the highest and the second highest Total Labor Force (in %) of 1992?
Make the answer very short. 12.17. What is the difference between the highest and the second highest Total Labor Force (in %) in 1993?
Make the answer very short. 12.91. What is the difference between the highest and the lowest Total Labor Force (in %) of 1990?
Offer a very short reply. 16.45. What is the difference between the highest and the lowest Total Labor Force (in %) of 1991?
Provide a short and direct response. 16.19. What is the difference between the highest and the lowest Total Labor Force (in %) in 1992?
Keep it short and to the point. 16.1. What is the difference between the highest and the lowest Total Labor Force (in %) in 1993?
Your response must be concise. 16.17. 